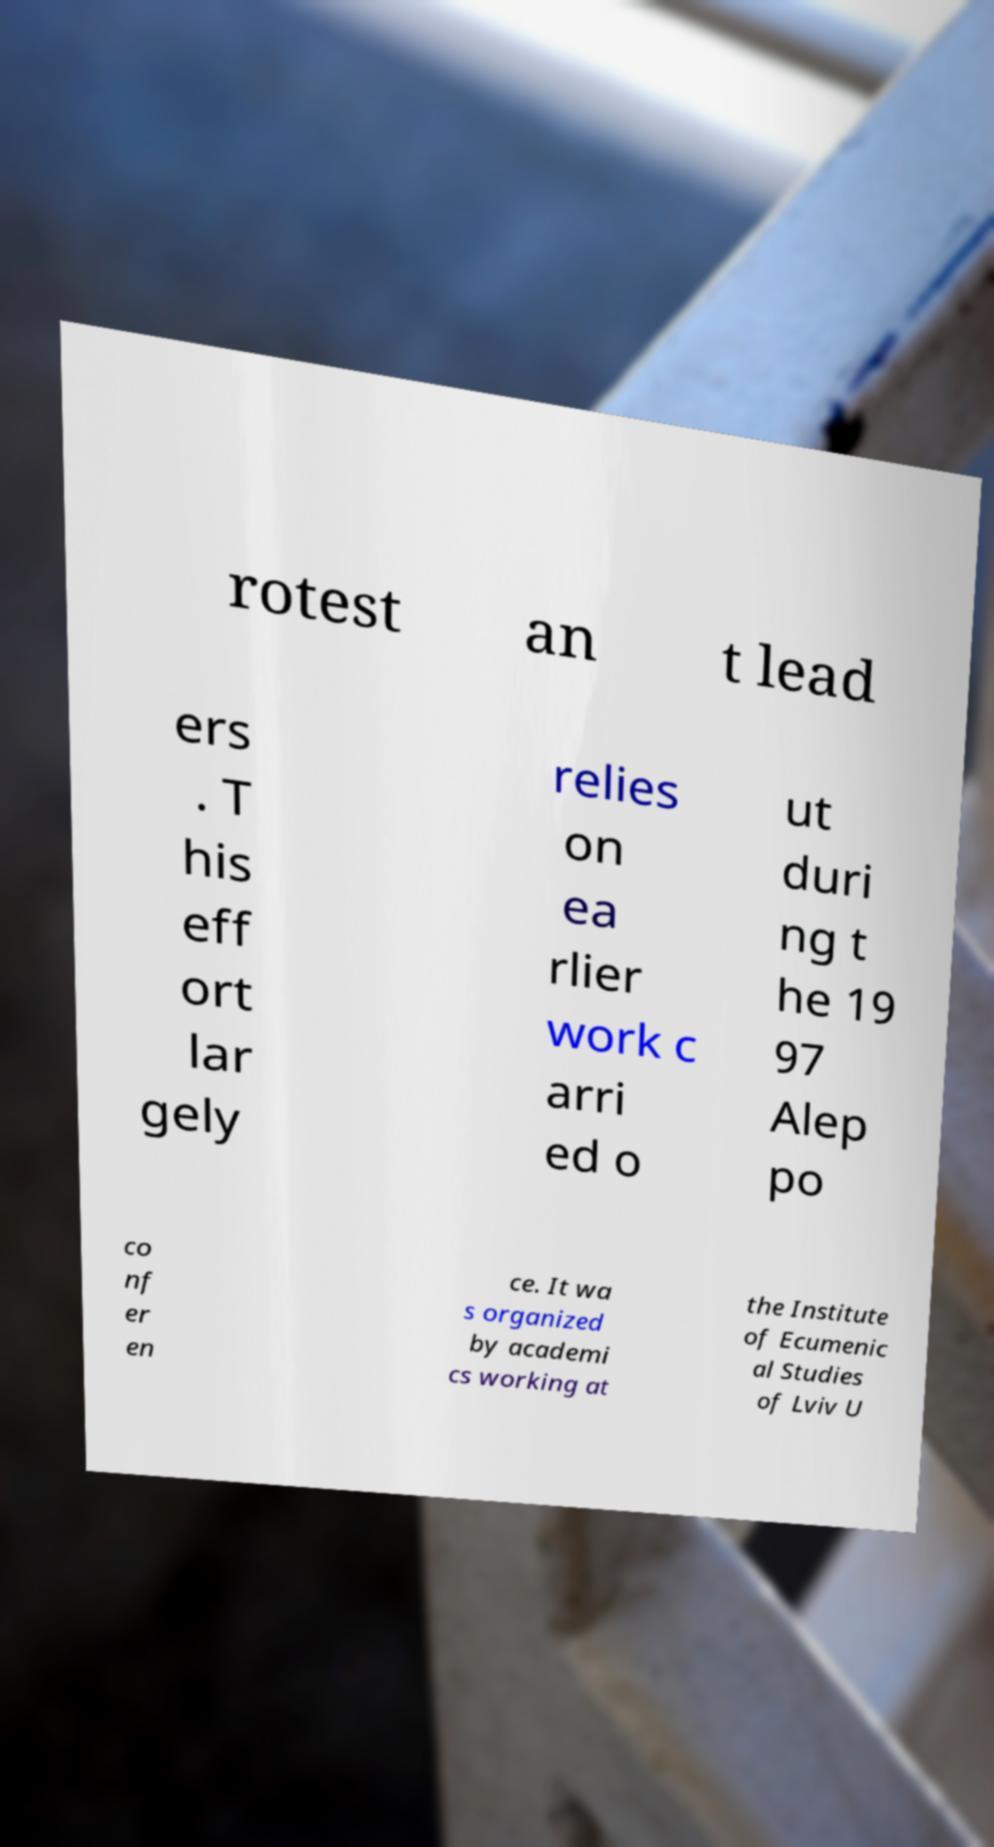For documentation purposes, I need the text within this image transcribed. Could you provide that? rotest an t lead ers . T his eff ort lar gely relies on ea rlier work c arri ed o ut duri ng t he 19 97 Alep po co nf er en ce. It wa s organized by academi cs working at the Institute of Ecumenic al Studies of Lviv U 